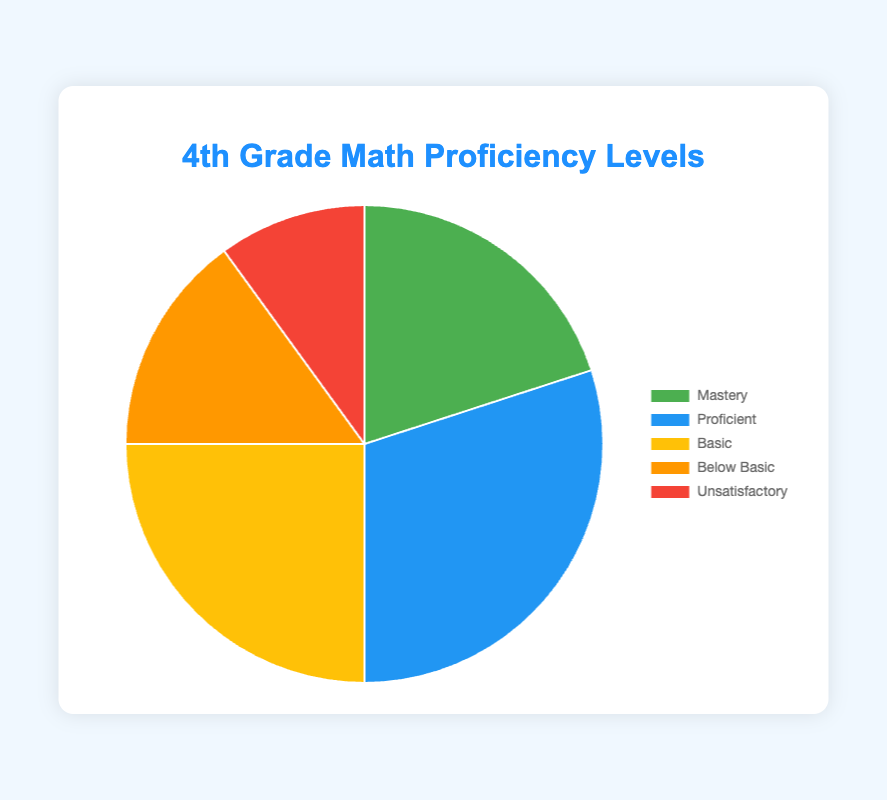What's the most common proficiency level among 4th graders? The largest segment in the pie chart represents the category with the highest percentage. Here, the "Proficient" category has the largest segment at 30%.
Answer: Proficient Which proficiency level has the smallest percentage? The segment with the smallest area represents the category with the smallest percentage. The "Unsatisfactory" category has the smallest segment at 10%.
Answer: Unsatisfactory What is the combined percentage of students at "Below Basic" and "Unsatisfactory" levels? Add the percentages of "Below Basic" (15%) and "Unsatisfactory" (10%). 15% + 10% = 25%.
Answer: 25% What is the difference between the percentages of students at "Mastery" and "Basic" levels? Subtract the percentage of "Mastery" (20%) from the percentage of "Basic" (25%). 25% - 20% = 5%.
Answer: 5% What percentage of students are at or above the "Proficient" level? Add the percentages of "Mastery" (20%) and "Proficient" (30%). 20% + 30% = 50%.
Answer: 50% Is the percentage of students at the "Basic" level greater than the percentage of students at the "Below Basic" level? Compare the percentages: "Basic" is 25% and "Below Basic" is 15%. 25% is greater than 15%.
Answer: Yes If you sum the percentages of "Mastery", "Proficient", and "Basic" levels, what percentage would that be? Add the percentages of "Mastery" (20%), "Proficient" (30%), and "Basic" (25%). 20% + 30% + 25% = 75%.
Answer: 75% What is the percentage difference between "Proficient" and "Unsatisfactory"? Subtract the percentage of "Unsatisfactory" (10%) from the percentage of "Proficient" (30%). 30% - 10% = 20%.
Answer: 20% Which proficiency level represented in blue, and what percentage does it account for? The "Proficient" level is represented in blue and accounts for 30%.
Answer: Proficient, 30% 